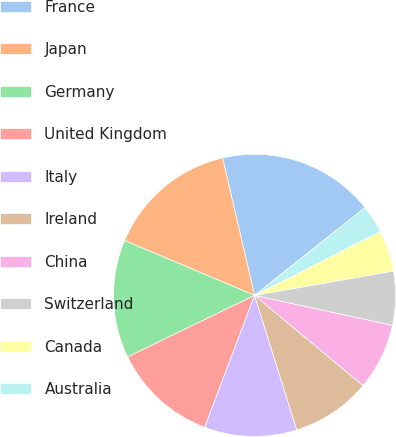Convert chart. <chart><loc_0><loc_0><loc_500><loc_500><pie_chart><fcel>France<fcel>Japan<fcel>Germany<fcel>United Kingdom<fcel>Italy<fcel>Ireland<fcel>China<fcel>Switzerland<fcel>Canada<fcel>Australia<nl><fcel>17.96%<fcel>15.01%<fcel>13.54%<fcel>12.06%<fcel>10.59%<fcel>9.12%<fcel>7.64%<fcel>6.17%<fcel>4.7%<fcel>3.22%<nl></chart> 